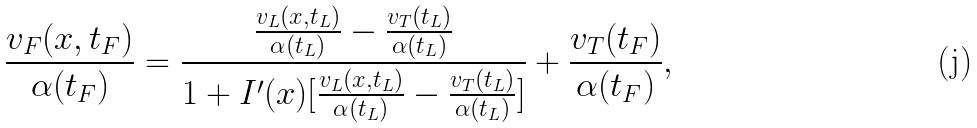<formula> <loc_0><loc_0><loc_500><loc_500>\frac { v _ { F } ( x , t _ { F } ) } { \alpha ( t _ { F } ) } = \frac { \frac { v _ { L } ( x , t _ { L } ) } { \alpha ( t _ { L } ) } - \frac { v _ { T } ( t _ { L } ) } { \alpha ( t _ { L } ) } } { 1 + I ^ { \prime } ( x ) [ \frac { v _ { L } ( x , t _ { L } ) } { \alpha ( t _ { L } ) } - \frac { v _ { T } ( t _ { L } ) } { \alpha ( t _ { L } ) } ] } + \frac { v _ { T } ( t _ { F } ) } { \alpha ( t _ { F } ) } ,</formula> 